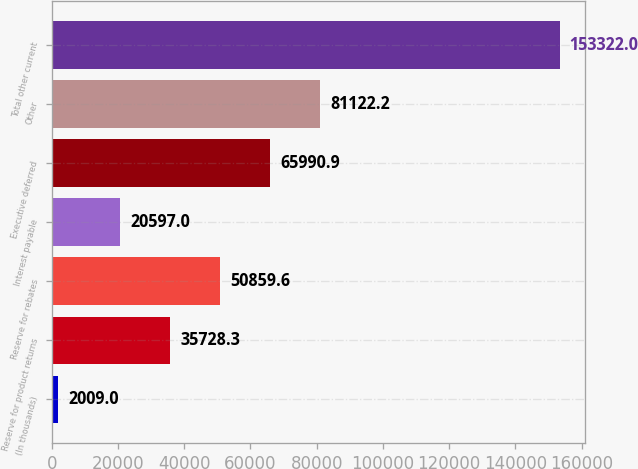Convert chart. <chart><loc_0><loc_0><loc_500><loc_500><bar_chart><fcel>(In thousands)<fcel>Reserve for product returns<fcel>Reserve for rebates<fcel>Interest payable<fcel>Executive deferred<fcel>Other<fcel>Total other current<nl><fcel>2009<fcel>35728.3<fcel>50859.6<fcel>20597<fcel>65990.9<fcel>81122.2<fcel>153322<nl></chart> 